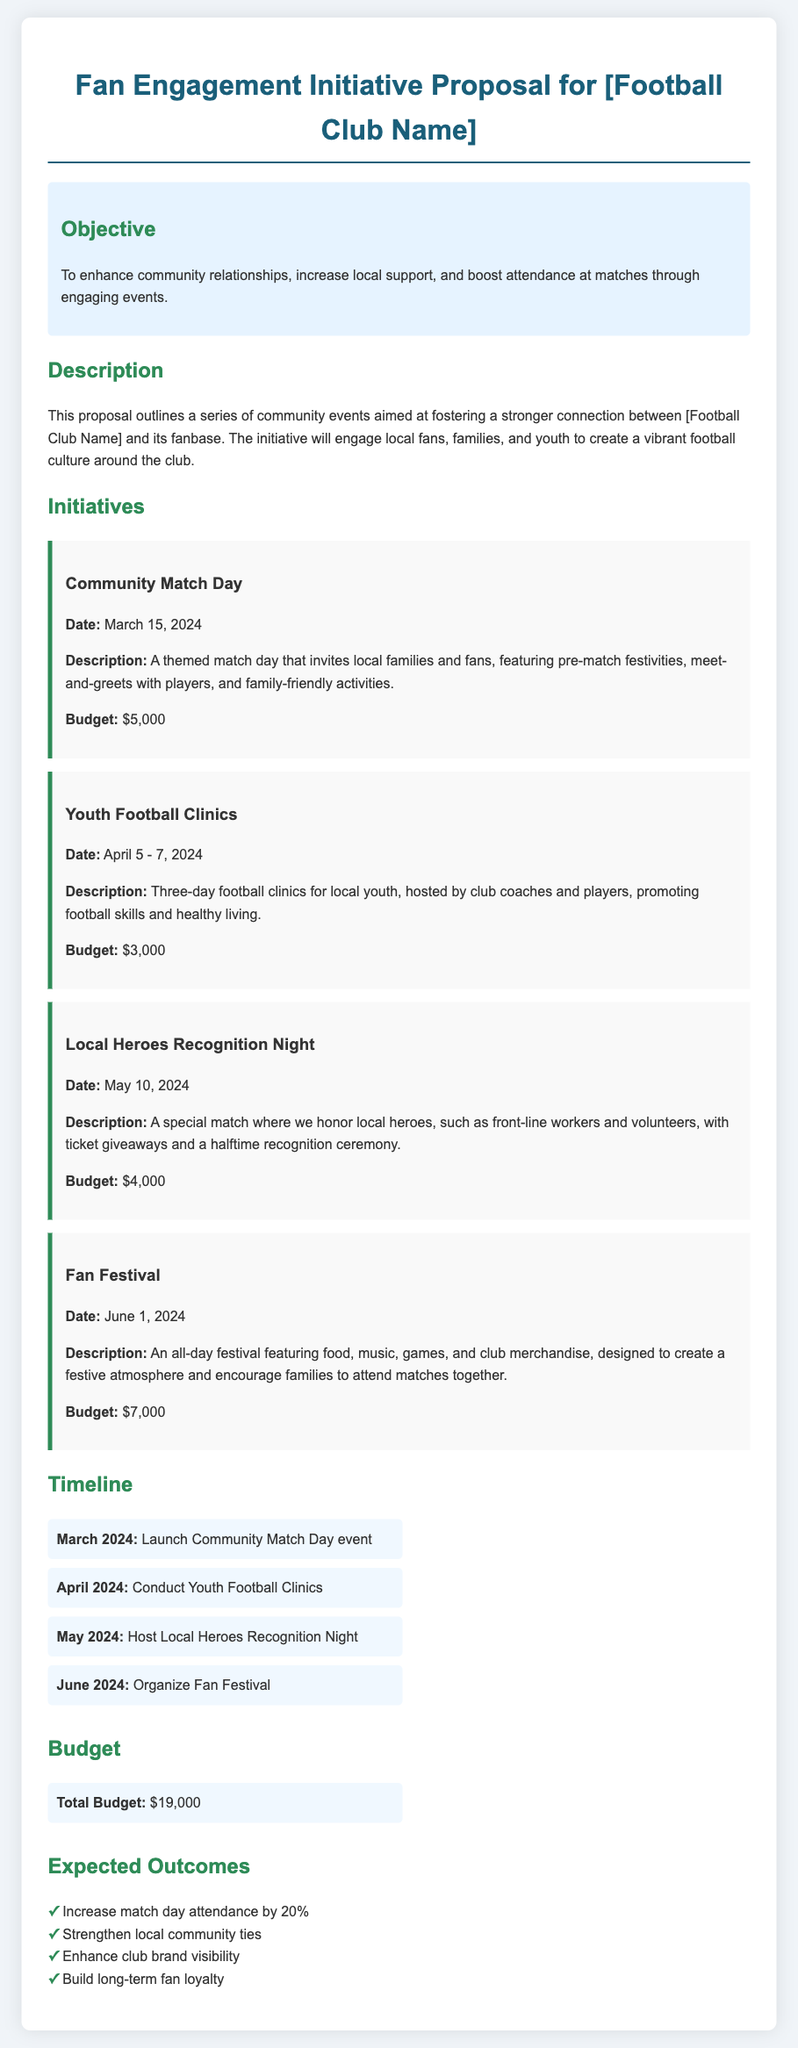What is the total budget for the initiative? The total budget is listed at the end of the document under the Budget section.
Answer: $19,000 When is the Community Match Day event scheduled? The date for the Community Match Day is specified in the initiatives section.
Answer: March 15, 2024 What is one of the expected outcomes of the initiative? Expected outcomes are listed in the Expected Outcomes section, which includes multiple outcomes.
Answer: Increase match day attendance by 20% How much is allocated for the Youth Football Clinics? The budget for each initiative is provided in the respective initiative descriptions.
Answer: $3,000 What is the purpose of the Local Heroes Recognition Night? The purpose is described in the initiative section, indicating a theme for the evening.
Answer: To honor local heroes In what month will the Fan Festival take place? The month for the Fan Festival is mentioned in the timeline section as well as in the initiative description.
Answer: June Who will host the Youth Football Clinics? This information is found in the initiative description about the clinics.
Answer: Club coaches and players What type of activities will be featured during the Community Match Day? The description of the Community Match Day gives insight into the type of activities planned.
Answer: Pre-match festivities, meet-and-greets, family-friendly activities What is the overall goal of the Fan Engagement Initiative? The objective section clearly states the main goal of the initiative.
Answer: To enhance community relationships 